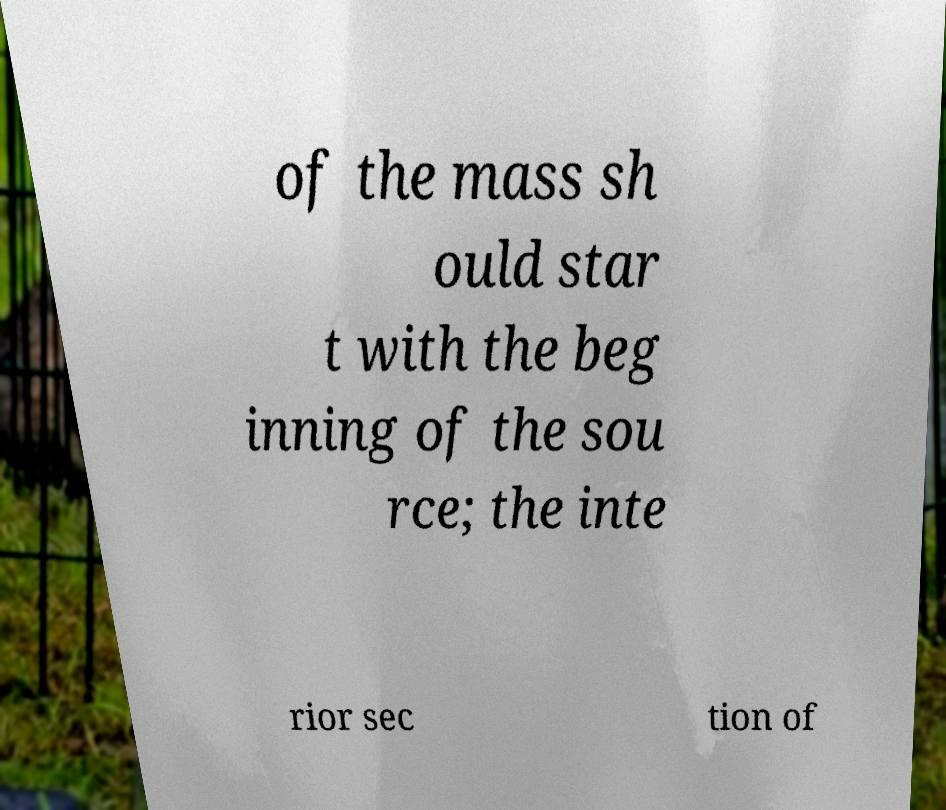Can you accurately transcribe the text from the provided image for me? of the mass sh ould star t with the beg inning of the sou rce; the inte rior sec tion of 